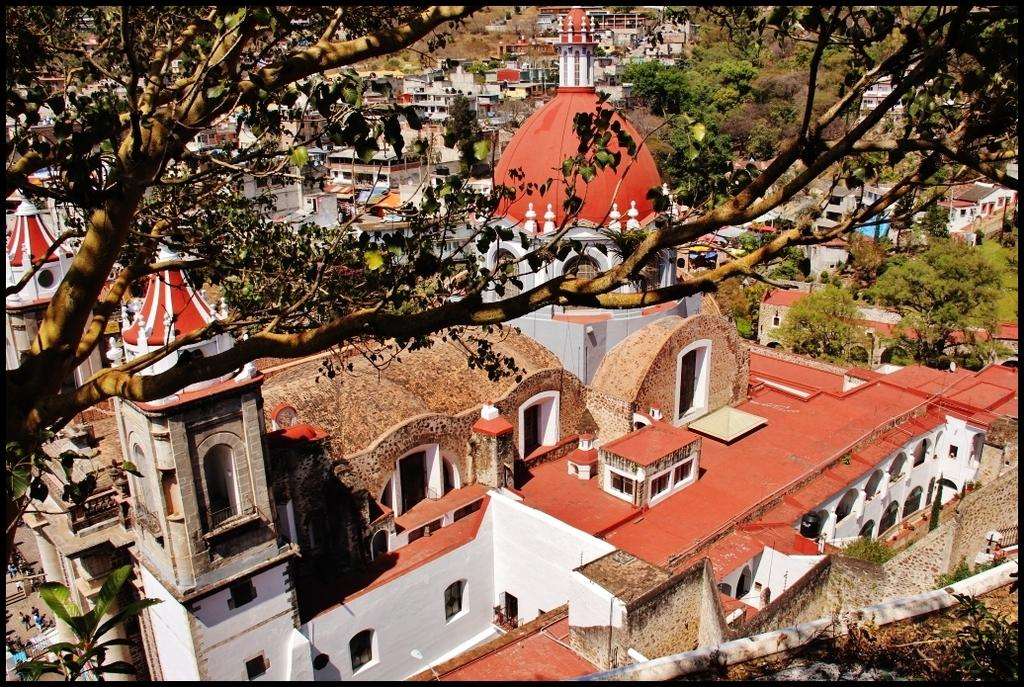What type of view is depicted in the image? The image shows an aerial view. What structures can be seen in the image? There are buildings and houses in the image. What type of vegetation is present in the image? Trees and plants are visible in the image. What type of reward is being offered to the quartz in the image? There is no quartz or reward present in the image. How does the toothpaste contribute to the image's composition? There is no toothpaste present in the image. 